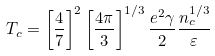Convert formula to latex. <formula><loc_0><loc_0><loc_500><loc_500>T _ { c } = \left [ \frac { 4 } { 7 } \right ] ^ { 2 } \left [ \frac { 4 \pi } { 3 } \right ] ^ { 1 / 3 } \frac { e ^ { 2 } \gamma } { 2 } \frac { n _ { c } ^ { 1 / 3 } } { \varepsilon }</formula> 